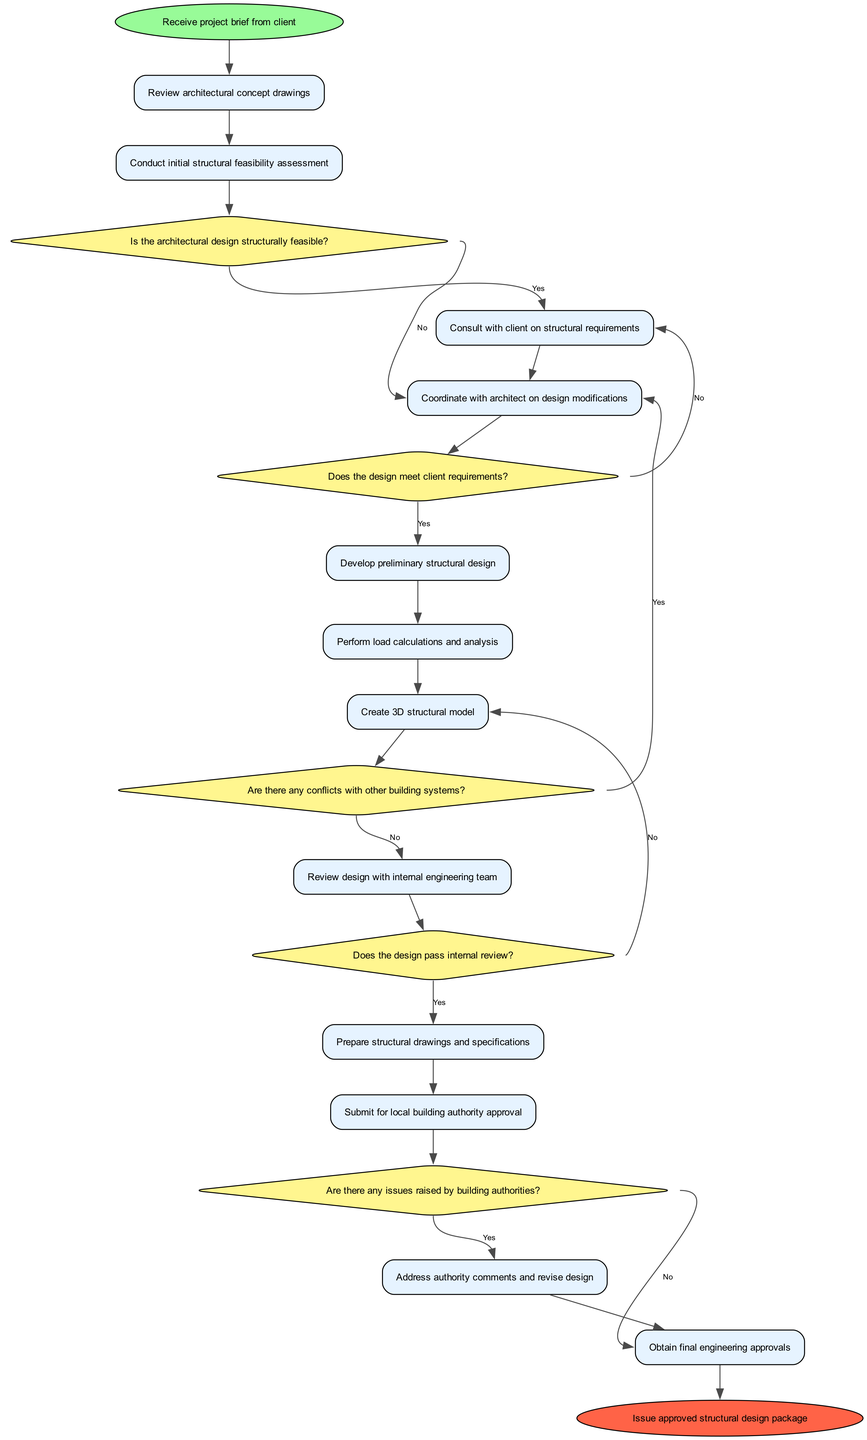What is the starting node of the diagram? The starting node is indicated at the top of the diagram, labeled as "Receive project brief from client."
Answer: Receive project brief from client How many decision nodes are in the diagram? By counting the nodes shaped like diamonds within the diagram, there are five decision nodes present.
Answer: 5 What activity follows the decision on architectural feasibility? After deciding on architectural feasibility, the diagram directs to the activity labeled "Consult with client on structural requirements."
Answer: Consult with client on structural requirements What is the last activity before obtaining engineering approvals? The last activity before reaching engineering approvals is "Address authority comments and revise design," which connects to the approval node.
Answer: Address authority comments and revise design What happens if the design does not pass the internal review? If the design does not pass the internal review, the diagram indicates a return to the previous activity, which is labeled "Create 3D structural model."
Answer: Create 3D structural model What is the final outcome of the process shown in the diagram? The final outcome node is labeled as "Issue approved structural design package," representing the end of the process.
Answer: Issue approved structural design package Which activity comes right before the submission to local building authority? The activity directly preceding the submission to local building authority is "Prepare structural drawings and specifications," making it essential for the next step.
Answer: Prepare structural drawings and specifications What is the decision that checks for conflicts with building systems? The decision node that checks for conflicts with other building systems is labeled "Are there any conflicts with other building systems?"
Answer: Are there any conflicts with other building systems? 